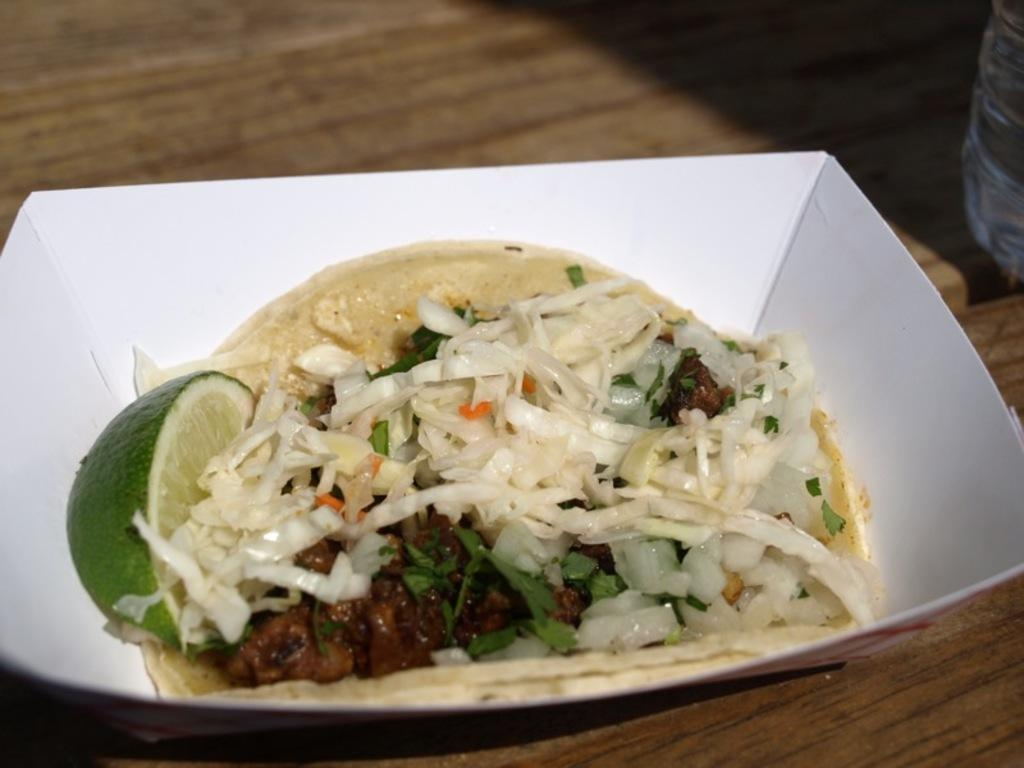What is the main food item in the image? There is a food item in a bowl in the image. What other ingredients can be seen in the image? There are onions and a lemon in the image. Where is the water bottle located in the image? The water bottle is on a wooden table in the image. What type of calculator is being used to measure the flavor of the food in the image? There is no calculator present in the image, and the flavor of the food cannot be measured in this context. 